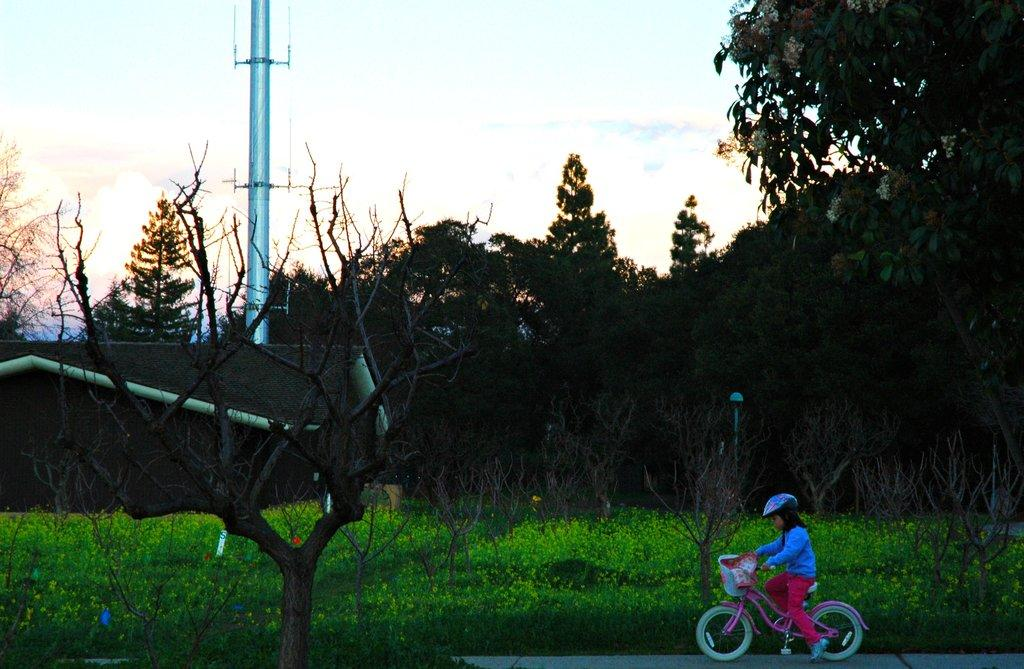What is the girl doing in the image? The girl is cycling in the image. Where is the girl cycling? The girl is on the road. What can be seen behind the girl? There are plants behind the girl. What other elements can be seen in the background of the image? There are trees, a pole, and the sky visible in the background of the image. How does the girl compare her cycling skills to a squirrel's in the image? There is no squirrel present in the image, and therefore no comparison can be made. 